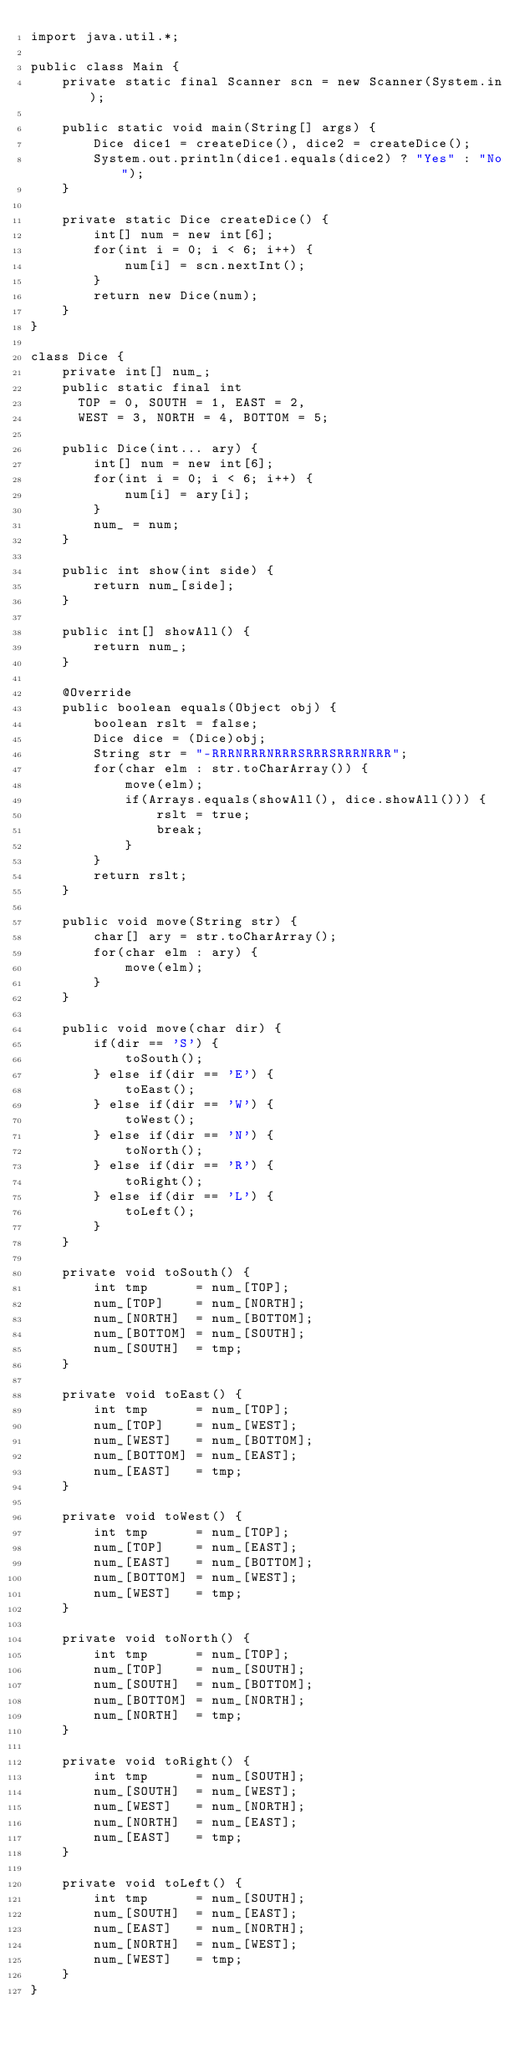Convert code to text. <code><loc_0><loc_0><loc_500><loc_500><_Java_>import java.util.*;

public class Main {
    private static final Scanner scn = new Scanner(System.in);
    
    public static void main(String[] args) {
        Dice dice1 = createDice(), dice2 = createDice();
        System.out.println(dice1.equals(dice2) ? "Yes" : "No");
    }
    
    private static Dice createDice() {
        int[] num = new int[6];
        for(int i = 0; i < 6; i++) {
            num[i] = scn.nextInt();
        }
        return new Dice(num);
    }
}

class Dice {
    private int[] num_;
    public static final int
      TOP = 0, SOUTH = 1, EAST = 2,
      WEST = 3, NORTH = 4, BOTTOM = 5;
    
    public Dice(int... ary) {
        int[] num = new int[6];
        for(int i = 0; i < 6; i++) {
            num[i] = ary[i];
        }
        num_ = num;
    }
    
    public int show(int side) {
        return num_[side];
    }
    
    public int[] showAll() {
        return num_;
    }
    
    @Override
    public boolean equals(Object obj) {
        boolean rslt = false;
        Dice dice = (Dice)obj;
        String str = "-RRRNRRRNRRRSRRRSRRRNRRR";
        for(char elm : str.toCharArray()) {
            move(elm);
            if(Arrays.equals(showAll(), dice.showAll())) {
                rslt = true;
                break;
            }
        }
        return rslt;
    }
    
    public void move(String str) {
        char[] ary = str.toCharArray();
        for(char elm : ary) {
            move(elm);
        }
    }
    
    public void move(char dir) {
        if(dir == 'S') {
            toSouth();
        } else if(dir == 'E') {
            toEast();
        } else if(dir == 'W') {
            toWest();
        } else if(dir == 'N') {
            toNorth();
        } else if(dir == 'R') {
            toRight();
        } else if(dir == 'L') {
            toLeft();
        }
    }
    
    private void toSouth() {
        int tmp      = num_[TOP];
        num_[TOP]    = num_[NORTH];
        num_[NORTH]  = num_[BOTTOM];
        num_[BOTTOM] = num_[SOUTH];
        num_[SOUTH]  = tmp;
    }
    
    private void toEast() {
        int tmp      = num_[TOP];
        num_[TOP]    = num_[WEST];
        num_[WEST]   = num_[BOTTOM];
        num_[BOTTOM] = num_[EAST];
        num_[EAST]   = tmp;
    }
    
    private void toWest() {
        int tmp      = num_[TOP];
        num_[TOP]    = num_[EAST];
        num_[EAST]   = num_[BOTTOM];
        num_[BOTTOM] = num_[WEST];
        num_[WEST]   = tmp;
    }
    
    private void toNorth() {
        int tmp      = num_[TOP];
        num_[TOP]    = num_[SOUTH];
        num_[SOUTH]  = num_[BOTTOM];
        num_[BOTTOM] = num_[NORTH];
        num_[NORTH]  = tmp;
    }
    
    private void toRight() {
        int tmp      = num_[SOUTH];
        num_[SOUTH]  = num_[WEST];
        num_[WEST]   = num_[NORTH];
        num_[NORTH]  = num_[EAST];
        num_[EAST]   = tmp;
    }
    
    private void toLeft() {
        int tmp      = num_[SOUTH];
        num_[SOUTH]  = num_[EAST];
        num_[EAST]   = num_[NORTH];
        num_[NORTH]  = num_[WEST];
        num_[WEST]   = tmp;
    }
}</code> 